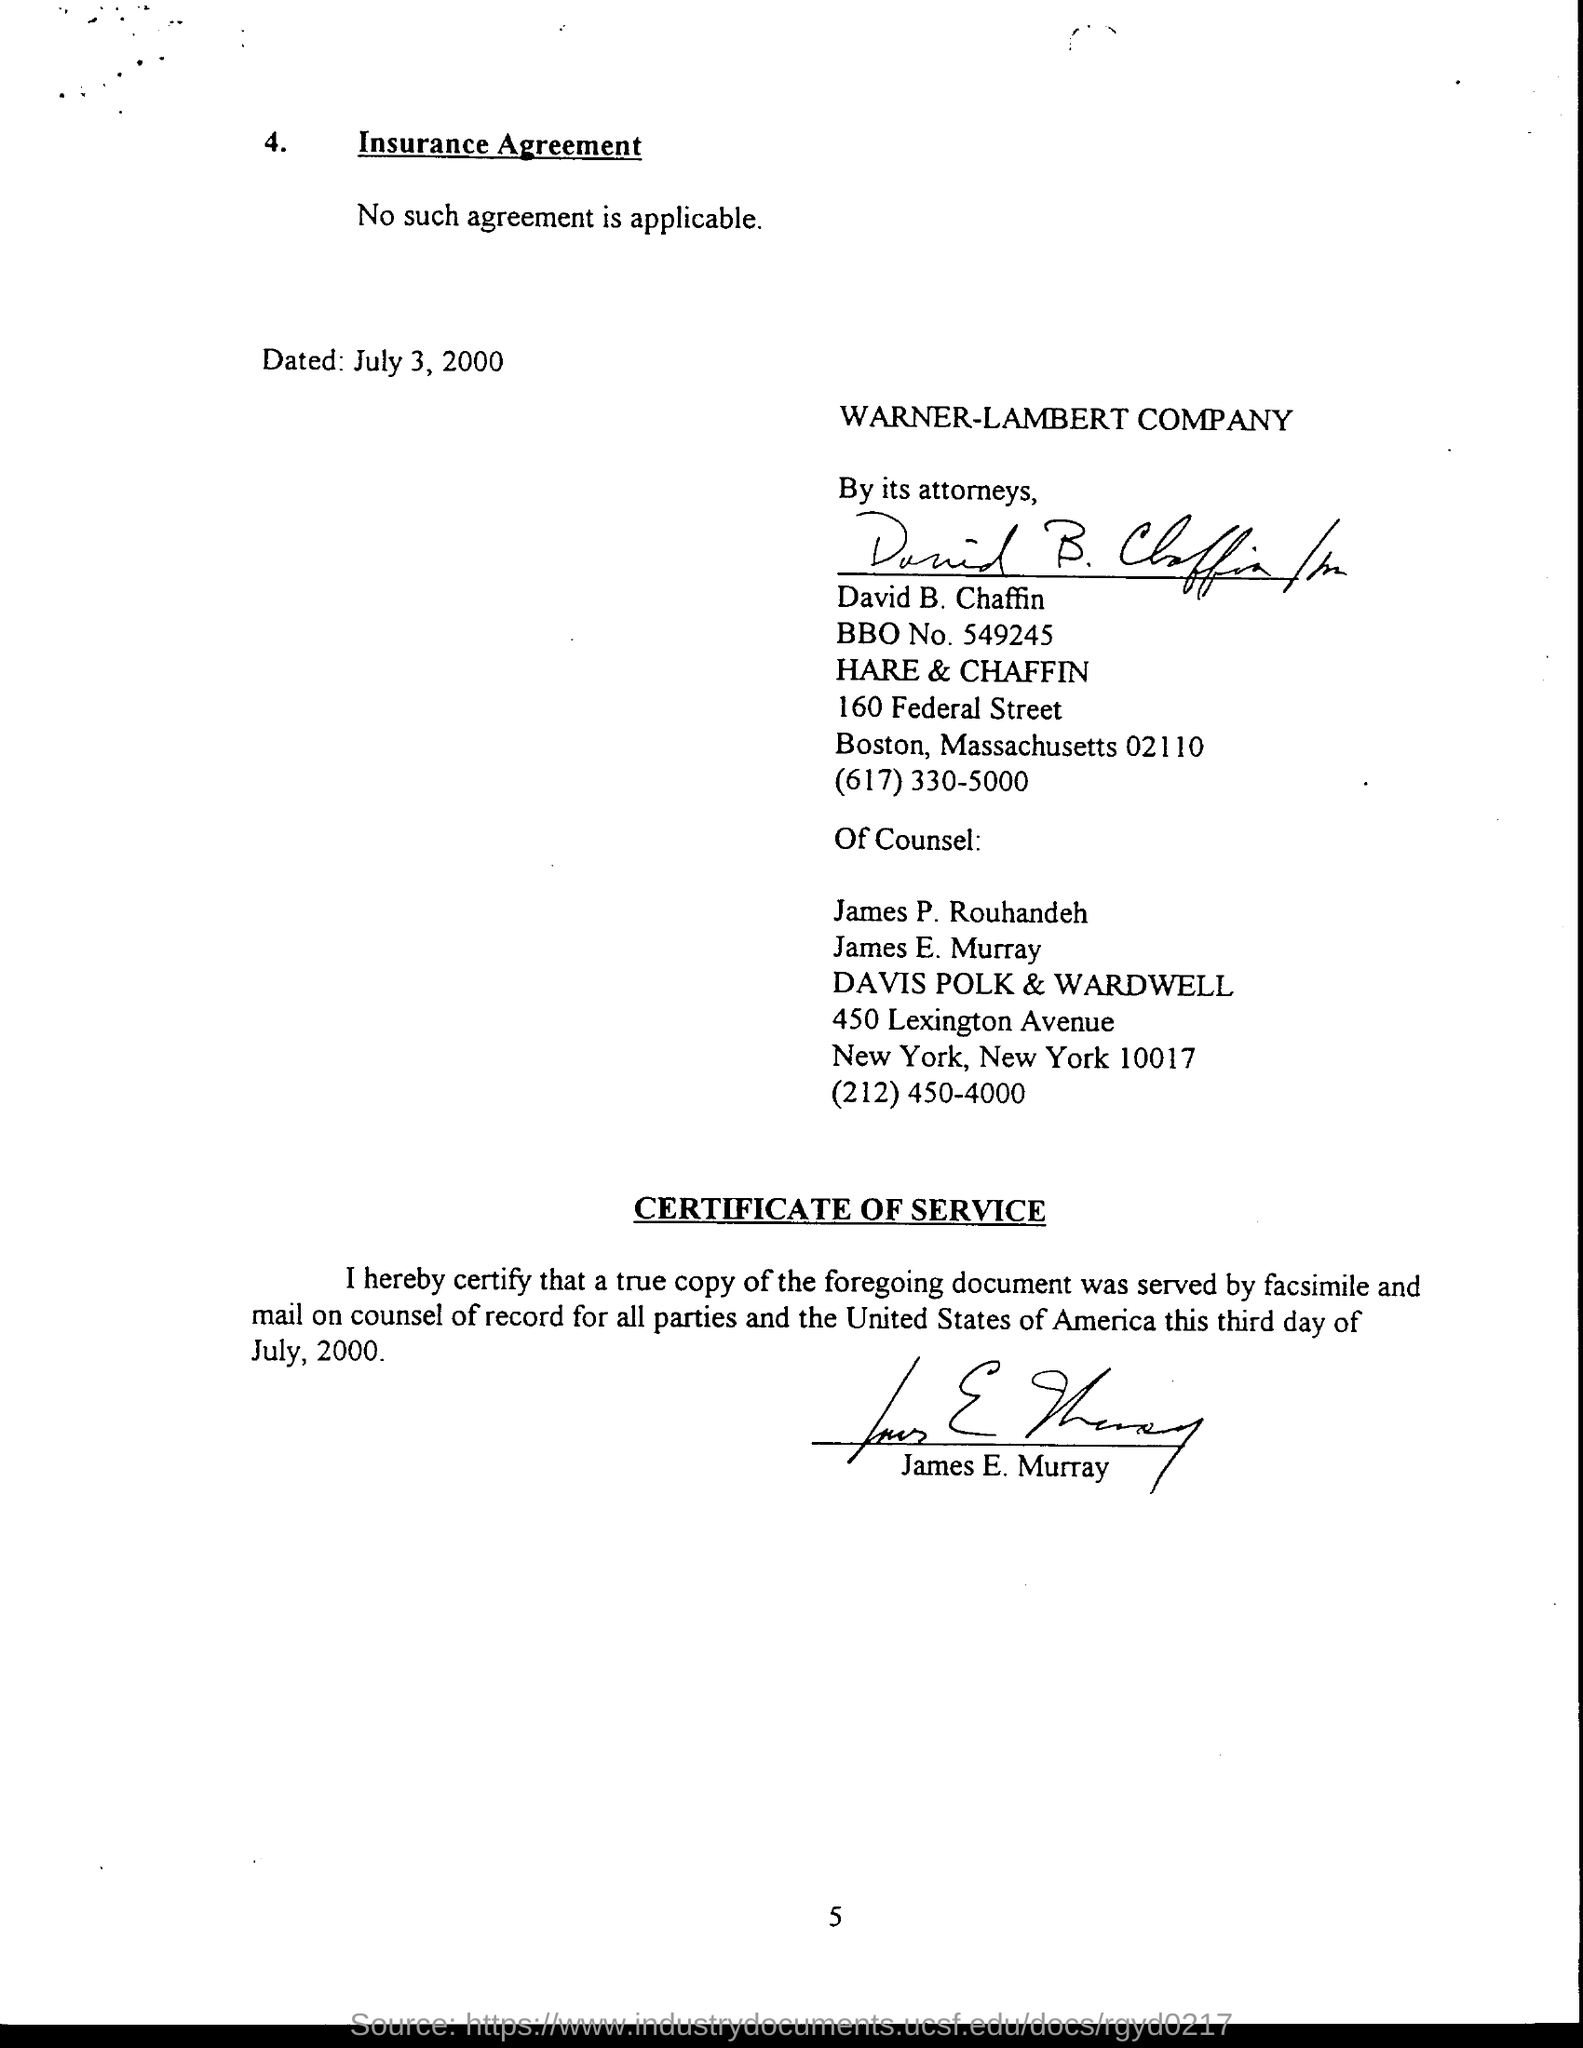Highlight a few significant elements in this photo. WARNER-LAMBERT is the company that is being referred to. The agreement was dated July 3, 2000. 